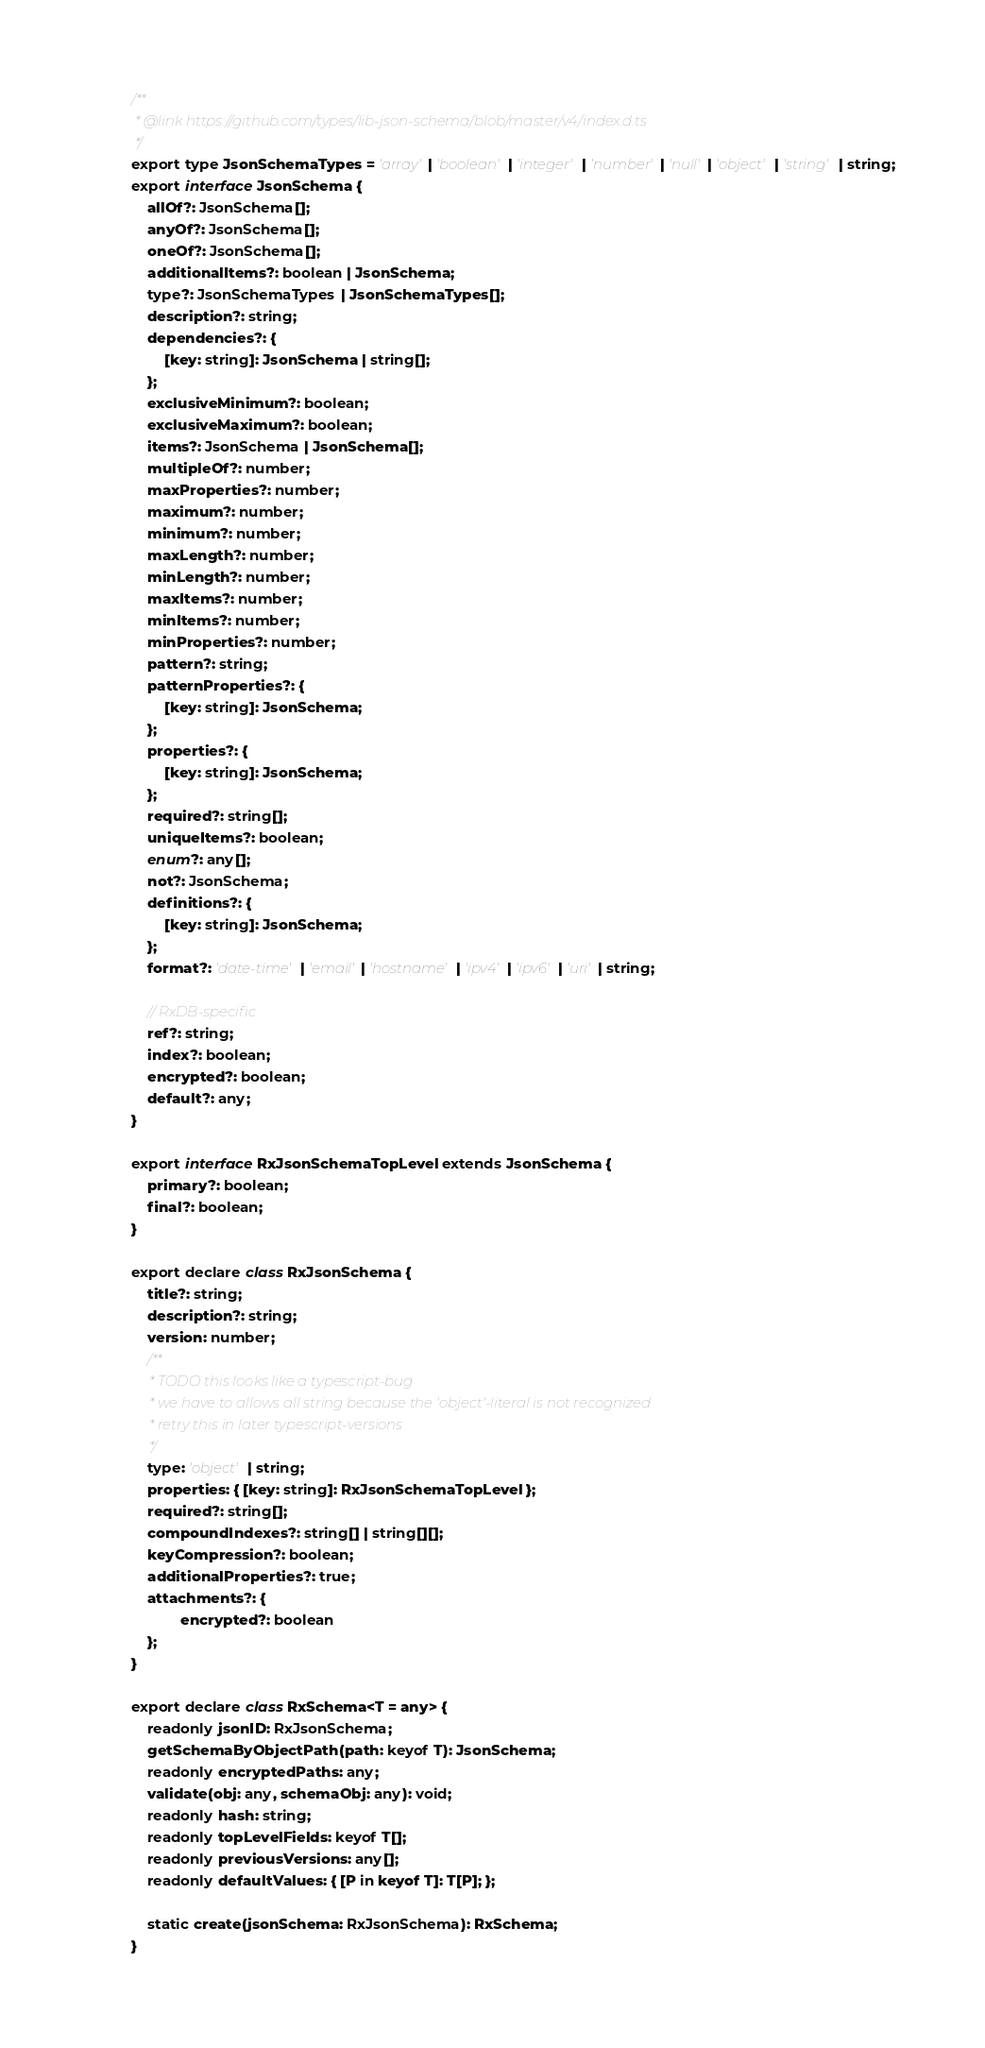<code> <loc_0><loc_0><loc_500><loc_500><_TypeScript_>/**
 * @link https://github.com/types/lib-json-schema/blob/master/v4/index.d.ts
 */
export type JsonSchemaTypes = 'array' | 'boolean' | 'integer' | 'number' | 'null' | 'object' | 'string' | string;
export interface JsonSchema {
    allOf?: JsonSchema[];
    anyOf?: JsonSchema[];
    oneOf?: JsonSchema[];
    additionalItems?: boolean | JsonSchema;
    type?: JsonSchemaTypes | JsonSchemaTypes[];
    description?: string;
    dependencies?: {
        [key: string]: JsonSchema | string[];
    };
    exclusiveMinimum?: boolean;
    exclusiveMaximum?: boolean;
    items?: JsonSchema | JsonSchema[];
    multipleOf?: number;
    maxProperties?: number;
    maximum?: number;
    minimum?: number;
    maxLength?: number;
    minLength?: number;
    maxItems?: number;
    minItems?: number;
    minProperties?: number;
    pattern?: string;
    patternProperties?: {
        [key: string]: JsonSchema;
    };
    properties?: {
        [key: string]: JsonSchema;
    };
    required?: string[];
    uniqueItems?: boolean;
    enum?: any[];
    not?: JsonSchema;
    definitions?: {
        [key: string]: JsonSchema;
    };
    format?: 'date-time' | 'email' | 'hostname' | 'ipv4' | 'ipv6' | 'uri' | string;

    // RxDB-specific
    ref?: string;
    index?: boolean;
    encrypted?: boolean;
    default?: any;
}

export interface RxJsonSchemaTopLevel extends JsonSchema {
    primary?: boolean;
    final?: boolean;
}

export declare class RxJsonSchema {
    title?: string;
    description?: string;
    version: number;
    /**
     * TODO this looks like a typescript-bug
     * we have to allows all string because the 'object'-literal is not recognized
     * retry this in later typescript-versions
     */
    type: 'object' | string;
    properties: { [key: string]: RxJsonSchemaTopLevel };
    required?: string[];
    compoundIndexes?: string[] | string[][];
    keyCompression?: boolean;
    additionalProperties?: true;
    attachments?: {
            encrypted?: boolean
    };
}

export declare class RxSchema<T = any> {
    readonly jsonID: RxJsonSchema;
    getSchemaByObjectPath(path: keyof T): JsonSchema;
    readonly encryptedPaths: any;
    validate(obj: any, schemaObj: any): void;
    readonly hash: string;
    readonly topLevelFields: keyof T[];
    readonly previousVersions: any[];
    readonly defaultValues: { [P in keyof T]: T[P]; };

    static create(jsonSchema: RxJsonSchema): RxSchema;
}
</code> 